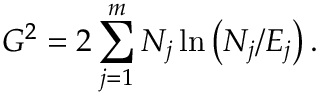<formula> <loc_0><loc_0><loc_500><loc_500>G ^ { 2 } = 2 \sum _ { j = 1 } ^ { m } N _ { j } \ln \left ( N _ { j } / E _ { j } \right ) .</formula> 